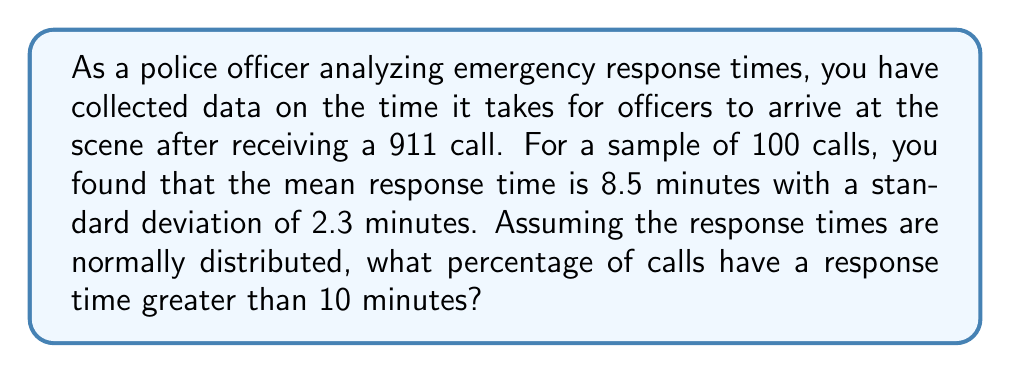Show me your answer to this math problem. To solve this problem, we need to use the concept of z-scores and the standard normal distribution.

1. First, we calculate the z-score for a response time of 10 minutes:

   $$ z = \frac{x - \mu}{\sigma} $$

   Where:
   $x$ = the value we're interested in (10 minutes)
   $\mu$ = the mean (8.5 minutes)
   $\sigma$ = the standard deviation (2.3 minutes)

   $$ z = \frac{10 - 8.5}{2.3} \approx 0.6522 $$

2. This z-score represents the number of standard deviations that 10 minutes is above the mean.

3. We want to find the probability of a response time being greater than 10 minutes, which is equivalent to finding the area under the standard normal curve to the right of z = 0.6522.

4. Using a standard normal table or a statistical calculator, we can find that the area to the right of z = 0.6522 is approximately 0.2571.

5. To convert this to a percentage, we multiply by 100:

   $$ 0.2571 \times 100 \approx 25.71\% $$

Therefore, approximately 25.71% of calls have a response time greater than 10 minutes.
Answer: 25.71% 